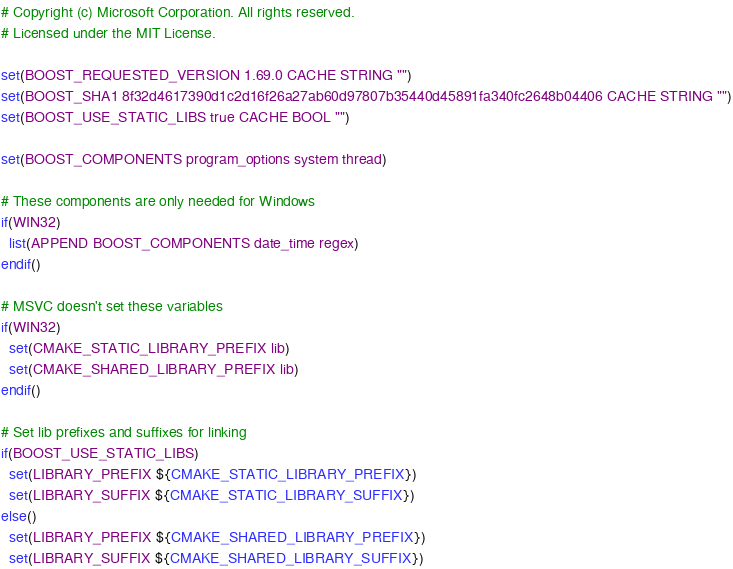<code> <loc_0><loc_0><loc_500><loc_500><_CMake_># Copyright (c) Microsoft Corporation. All rights reserved.
# Licensed under the MIT License.

set(BOOST_REQUESTED_VERSION 1.69.0 CACHE STRING "")
set(BOOST_SHA1 8f32d4617390d1c2d16f26a27ab60d97807b35440d45891fa340fc2648b04406 CACHE STRING "")
set(BOOST_USE_STATIC_LIBS true CACHE BOOL "")

set(BOOST_COMPONENTS program_options system thread)

# These components are only needed for Windows
if(WIN32)
  list(APPEND BOOST_COMPONENTS date_time regex)
endif()

# MSVC doesn't set these variables
if(WIN32)
  set(CMAKE_STATIC_LIBRARY_PREFIX lib)
  set(CMAKE_SHARED_LIBRARY_PREFIX lib)
endif()

# Set lib prefixes and suffixes for linking
if(BOOST_USE_STATIC_LIBS)
  set(LIBRARY_PREFIX ${CMAKE_STATIC_LIBRARY_PREFIX})
  set(LIBRARY_SUFFIX ${CMAKE_STATIC_LIBRARY_SUFFIX})
else()
  set(LIBRARY_PREFIX ${CMAKE_SHARED_LIBRARY_PREFIX})
  set(LIBRARY_SUFFIX ${CMAKE_SHARED_LIBRARY_SUFFIX})</code> 